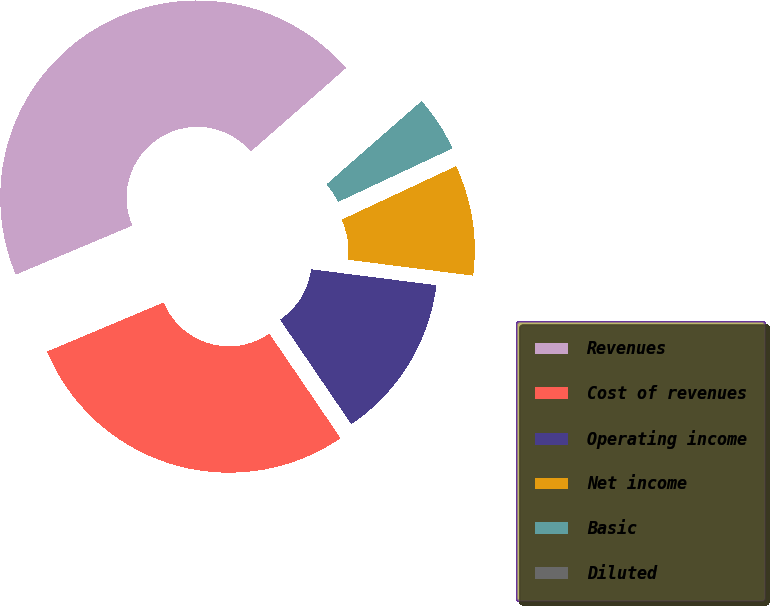Convert chart. <chart><loc_0><loc_0><loc_500><loc_500><pie_chart><fcel>Revenues<fcel>Cost of revenues<fcel>Operating income<fcel>Net income<fcel>Basic<fcel>Diluted<nl><fcel>44.89%<fcel>28.18%<fcel>13.47%<fcel>8.98%<fcel>4.49%<fcel>0.0%<nl></chart> 